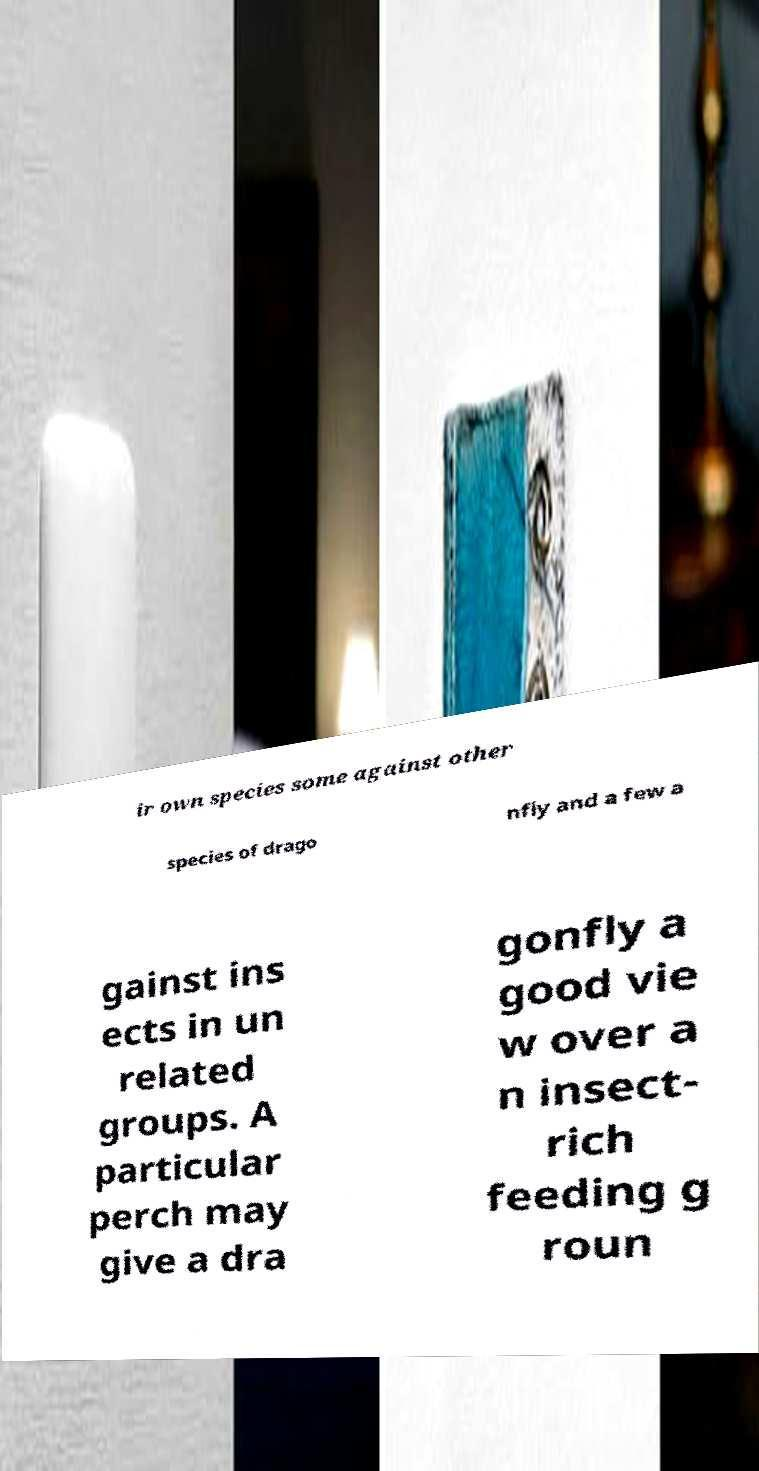Could you assist in decoding the text presented in this image and type it out clearly? ir own species some against other species of drago nfly and a few a gainst ins ects in un related groups. A particular perch may give a dra gonfly a good vie w over a n insect- rich feeding g roun 